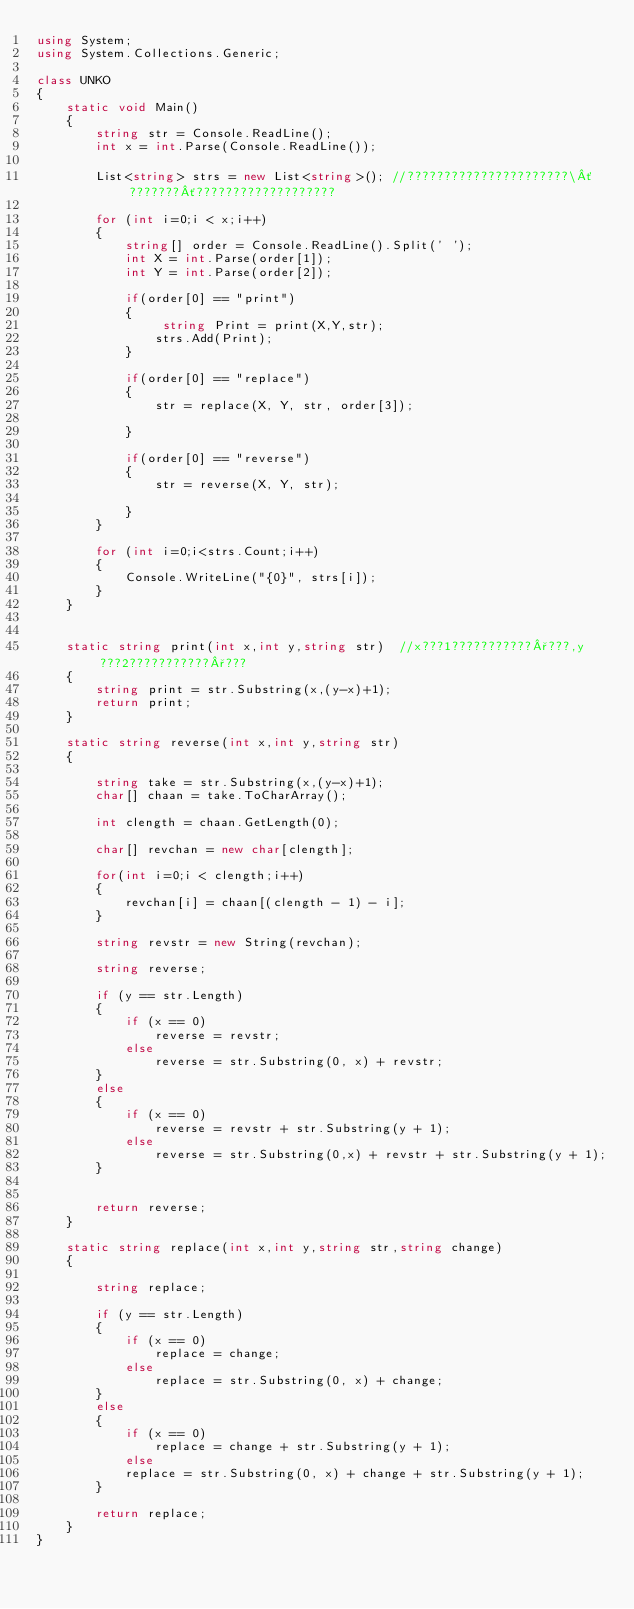Convert code to text. <code><loc_0><loc_0><loc_500><loc_500><_C#_>using System;
using System.Collections.Generic;

class UNKO
{
    static void Main()
    {
        string str = Console.ReadLine();
        int x = int.Parse(Console.ReadLine());

        List<string> strs = new List<string>(); //??????????????????????\´???????´???????????????????

        for (int i=0;i < x;i++)
        {
            string[] order = Console.ReadLine().Split(' ');
            int X = int.Parse(order[1]);
            int Y = int.Parse(order[2]);
            
            if(order[0] == "print")
            {
                 string Print = print(X,Y,str);   
                strs.Add(Print);
            }

            if(order[0] == "replace")
            {
                str = replace(X, Y, str, order[3]);
              
            }

            if(order[0] == "reverse")
            {
                str = reverse(X, Y, str);
           
            }
        }

        for (int i=0;i<strs.Count;i++)
        {
            Console.WriteLine("{0}", strs[i]);               
        }
    }


    static string print(int x,int y,string str)  //x???1???????????°???,y???2???????????°???
    {
        string print = str.Substring(x,(y-x)+1);
        return print;
    }

    static string reverse(int x,int y,string str)
    {

        string take = str.Substring(x,(y-x)+1);
        char[] chaan = take.ToCharArray();

        int clength = chaan.GetLength(0);

        char[] revchan = new char[clength];

        for(int i=0;i < clength;i++)
        {
            revchan[i] = chaan[(clength - 1) - i];
        }

        string revstr = new String(revchan);

        string reverse;

        if (y == str.Length)
        {
            if (x == 0)
                reverse = revstr;
            else
                reverse = str.Substring(0, x) + revstr;
        }
        else
        {
            if (x == 0)
                reverse = revstr + str.Substring(y + 1);
            else
                reverse = str.Substring(0,x) + revstr + str.Substring(y + 1);
        }
      

        return reverse;
    }

    static string replace(int x,int y,string str,string change)
    {

        string replace;

        if (y == str.Length)
        {
            if (x == 0)
                replace = change;
            else
                replace = str.Substring(0, x) + change;
        }
        else
        {
            if (x == 0)
                replace = change + str.Substring(y + 1);
            else
            replace = str.Substring(0, x) + change + str.Substring(y + 1);
        }

        return replace;
    }
}</code> 